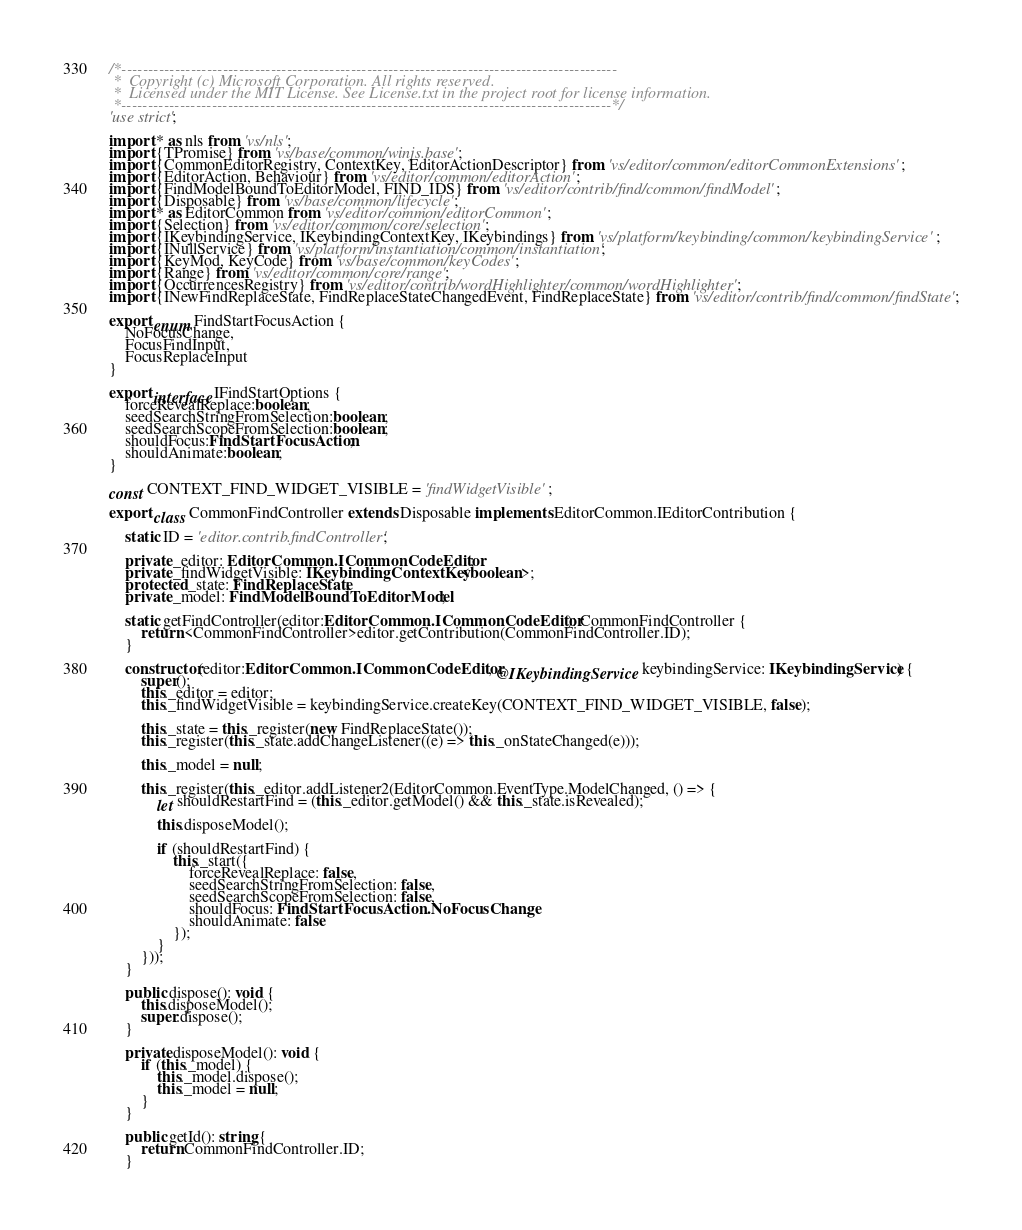<code> <loc_0><loc_0><loc_500><loc_500><_TypeScript_>/*---------------------------------------------------------------------------------------------
 *  Copyright (c) Microsoft Corporation. All rights reserved.
 *  Licensed under the MIT License. See License.txt in the project root for license information.
 *--------------------------------------------------------------------------------------------*/
'use strict';

import * as nls from 'vs/nls';
import {TPromise} from 'vs/base/common/winjs.base';
import {CommonEditorRegistry, ContextKey, EditorActionDescriptor} from 'vs/editor/common/editorCommonExtensions';
import {EditorAction, Behaviour} from 'vs/editor/common/editorAction';
import {FindModelBoundToEditorModel, FIND_IDS} from 'vs/editor/contrib/find/common/findModel';
import {Disposable} from 'vs/base/common/lifecycle';
import * as EditorCommon from 'vs/editor/common/editorCommon';
import {Selection} from 'vs/editor/common/core/selection';
import {IKeybindingService, IKeybindingContextKey, IKeybindings} from 'vs/platform/keybinding/common/keybindingService';
import {INullService} from 'vs/platform/instantiation/common/instantiation';
import {KeyMod, KeyCode} from 'vs/base/common/keyCodes';
import {Range} from 'vs/editor/common/core/range';
import {OccurrencesRegistry} from 'vs/editor/contrib/wordHighlighter/common/wordHighlighter';
import {INewFindReplaceState, FindReplaceStateChangedEvent, FindReplaceState} from 'vs/editor/contrib/find/common/findState';

export enum FindStartFocusAction {
	NoFocusChange,
	FocusFindInput,
	FocusReplaceInput
}

export interface IFindStartOptions {
	forceRevealReplace:boolean;
	seedSearchStringFromSelection:boolean;
	seedSearchScopeFromSelection:boolean;
	shouldFocus:FindStartFocusAction;
	shouldAnimate:boolean;
}

const CONTEXT_FIND_WIDGET_VISIBLE = 'findWidgetVisible';

export class CommonFindController extends Disposable implements EditorCommon.IEditorContribution {

	static ID = 'editor.contrib.findController';

	private _editor: EditorCommon.ICommonCodeEditor;
	private _findWidgetVisible: IKeybindingContextKey<boolean>;
	protected _state: FindReplaceState;
	private _model: FindModelBoundToEditorModel;

	static getFindController(editor:EditorCommon.ICommonCodeEditor): CommonFindController {
		return <CommonFindController>editor.getContribution(CommonFindController.ID);
	}

	constructor(editor:EditorCommon.ICommonCodeEditor, @IKeybindingService keybindingService: IKeybindingService) {
		super();
		this._editor = editor;
		this._findWidgetVisible = keybindingService.createKey(CONTEXT_FIND_WIDGET_VISIBLE, false);

		this._state = this._register(new FindReplaceState());
		this._register(this._state.addChangeListener((e) => this._onStateChanged(e)));

		this._model = null;

		this._register(this._editor.addListener2(EditorCommon.EventType.ModelChanged, () => {
			let shouldRestartFind = (this._editor.getModel() && this._state.isRevealed);

			this.disposeModel();

			if (shouldRestartFind) {
				this._start({
					forceRevealReplace: false,
					seedSearchStringFromSelection: false,
					seedSearchScopeFromSelection: false,
					shouldFocus: FindStartFocusAction.NoFocusChange,
					shouldAnimate: false
				});
			}
		}));
	}

	public dispose(): void {
		this.disposeModel();
		super.dispose();
	}

	private disposeModel(): void {
		if (this._model) {
			this._model.dispose();
			this._model = null;
		}
	}

	public getId(): string {
		return CommonFindController.ID;
	}
</code> 